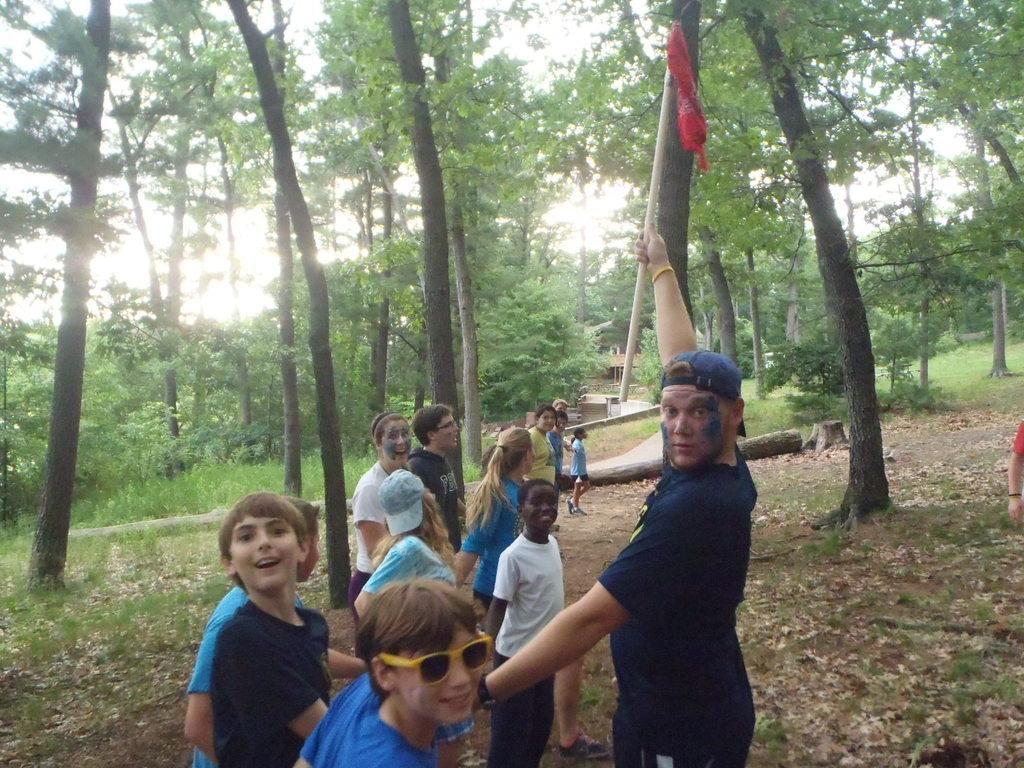In one or two sentences, can you explain what this image depicts? In this image there are some persons standing in the bottom of this image and the person at right side is holding a stick and there are some trees in the background. there is a sky on the top of this image. 